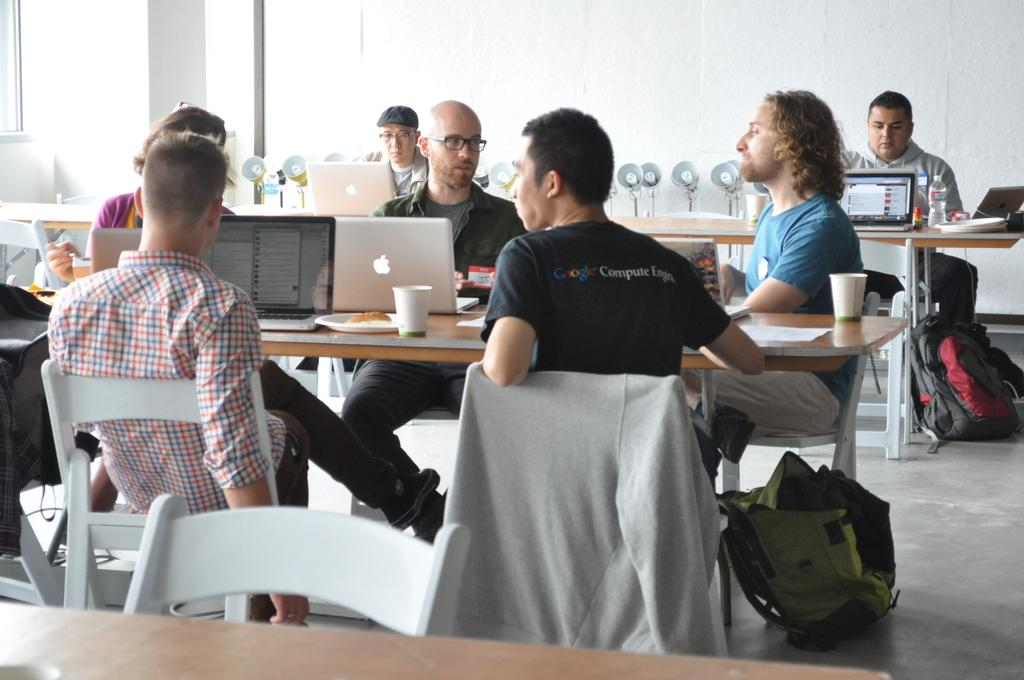<image>
Offer a succinct explanation of the picture presented. A group of men sitting at tables with laptops and one has a shirt with compute written on the back. 